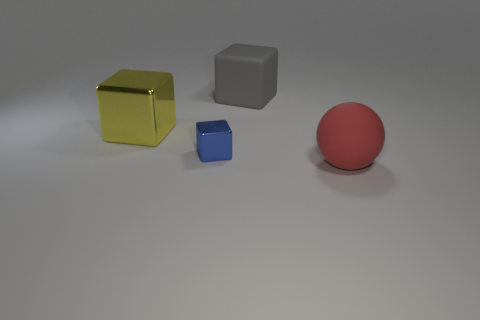Add 3 matte balls. How many objects exist? 7 Subtract all small metal cubes. How many cubes are left? 2 Subtract all blue blocks. How many blocks are left? 2 Subtract 1 balls. How many balls are left? 0 Subtract all brown balls. Subtract all yellow blocks. How many balls are left? 1 Subtract all tiny red rubber spheres. Subtract all blue blocks. How many objects are left? 3 Add 1 rubber objects. How many rubber objects are left? 3 Add 3 large red objects. How many large red objects exist? 4 Subtract 0 yellow cylinders. How many objects are left? 4 Subtract all cubes. How many objects are left? 1 